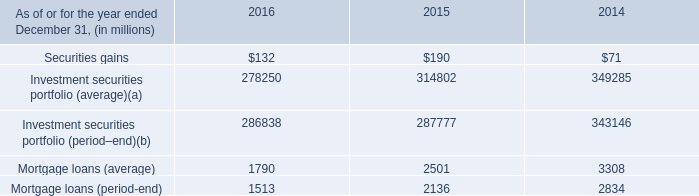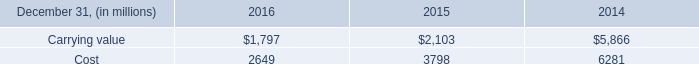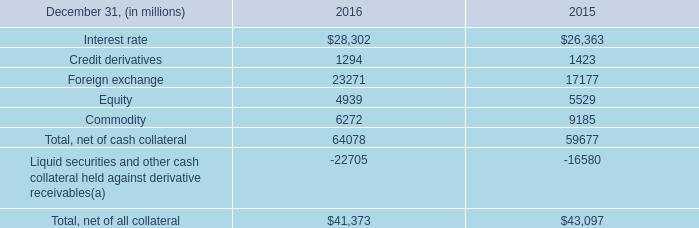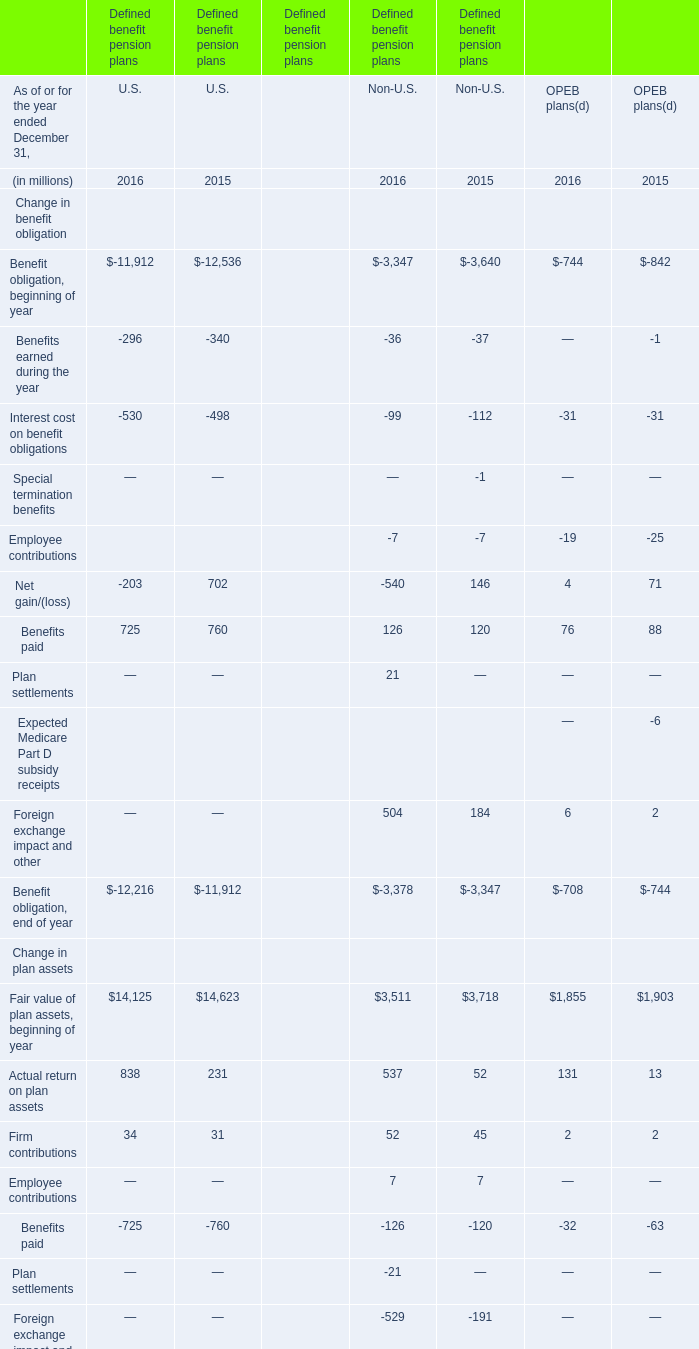What's the 50 % of the Fair value of plan assets, beginning of year for the year 2015 ended December 31 for Non-U.S.? (in million) 
Computations: (0.5 * 3718)
Answer: 1859.0. 